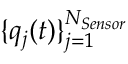<formula> <loc_0><loc_0><loc_500><loc_500>\{ q _ { j } ( t ) \} _ { j = 1 } ^ { N _ { S e n s o r } }</formula> 